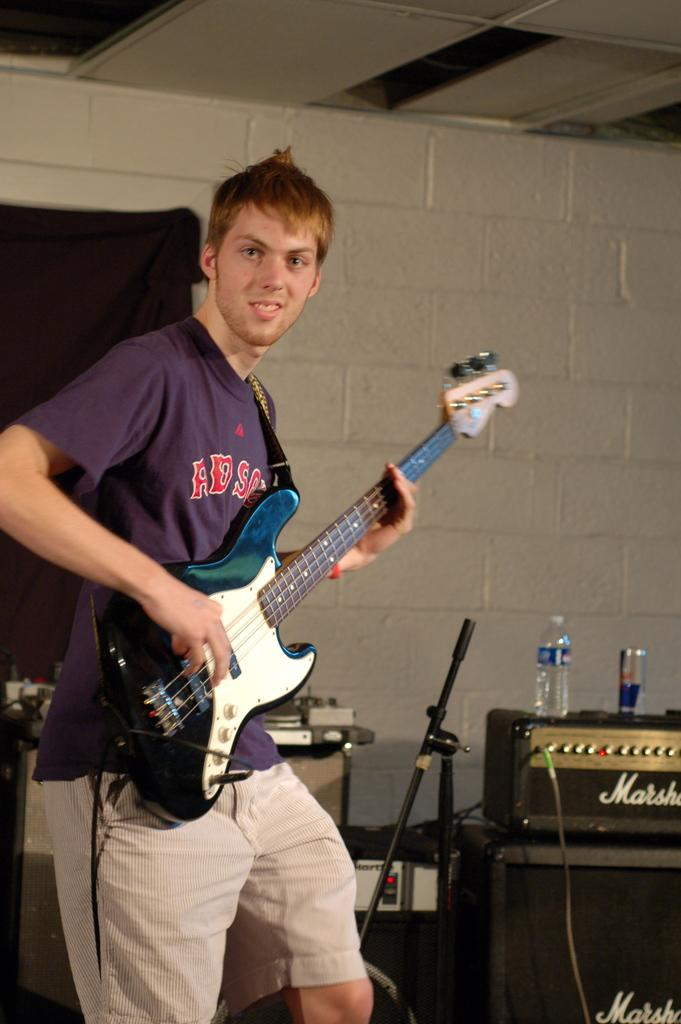Who is present in the image? There is a man in the image. What is the man holding in the image? The man is holding a guitar. What can be seen in the background of the image? There is a wall, equipment, a bottle, and a can visible in the background. What type of card is being played in the image? There is no card or card game present in the image. Can you describe the sky in the image? The provided facts do not mention the sky, so it cannot be described based on the information given. 